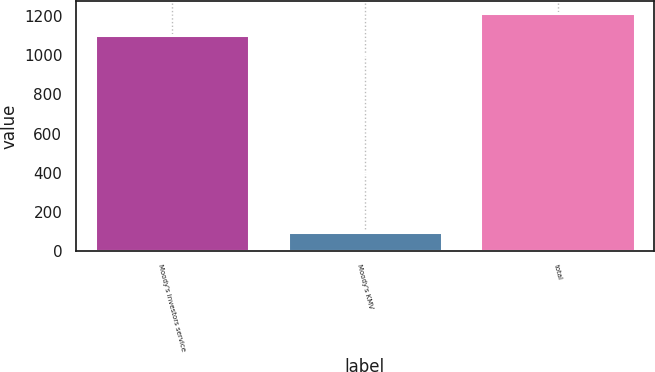Convert chart. <chart><loc_0><loc_0><loc_500><loc_500><bar_chart><fcel>Moody's investors service<fcel>Moody's KMV<fcel>total<nl><fcel>1106<fcel>97<fcel>1216.6<nl></chart> 